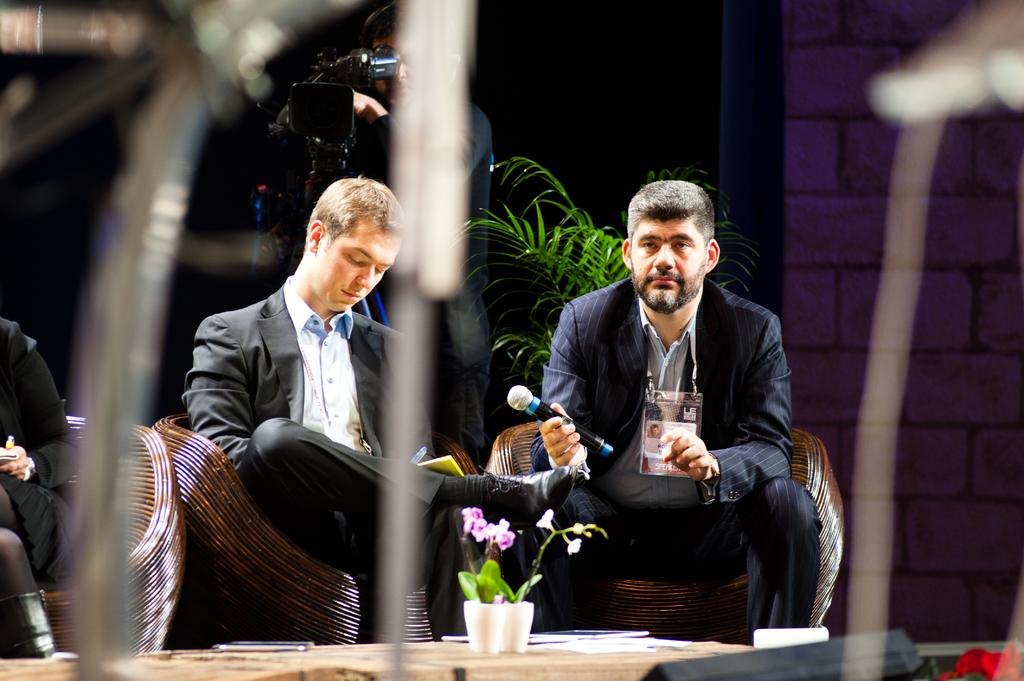How many people are sitting on chairs in the image? There are three persons sitting on chairs in the image. What is one of the persons holding in his hand? One of the persons is holding a mic in his hand. Can you describe any other objects or plants in the image? Yes, there is a plant visible in the image. What is the person beside the plant doing? The person beside the plant is video graphing. What type of slave is depicted in the image? There is no depiction of a slave in the image; it features three persons sitting on chairs, one of whom is holding a mic. Can you tell me the size of the skateboard in the image? There is no skateboard present in the image. 